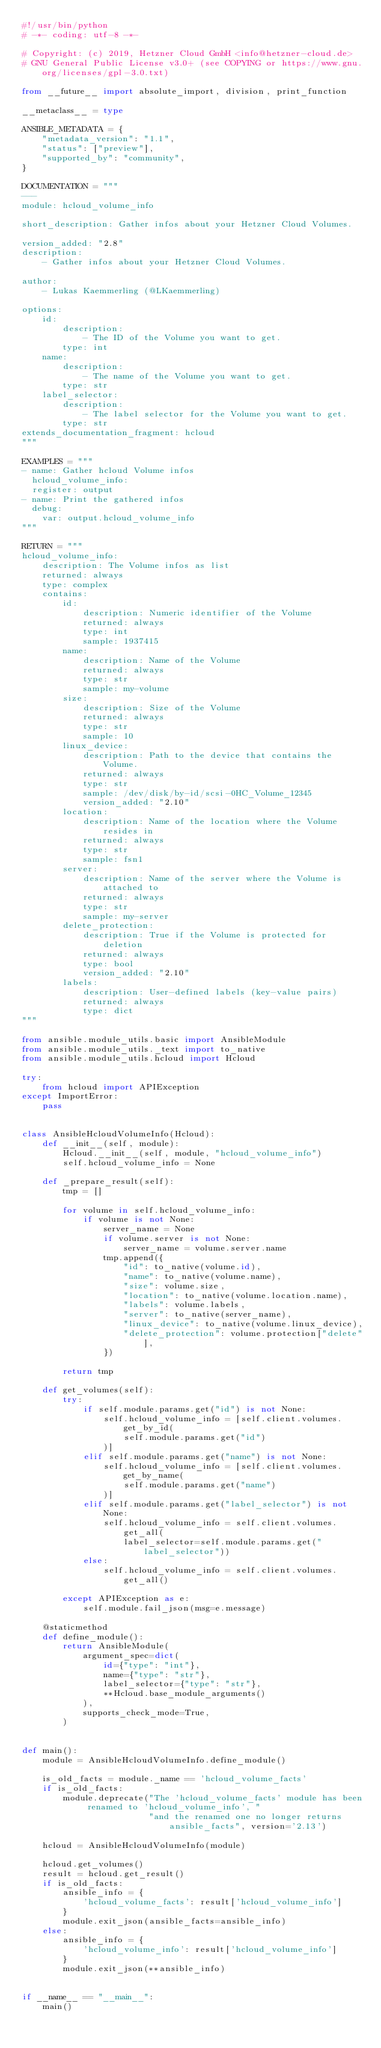Convert code to text. <code><loc_0><loc_0><loc_500><loc_500><_Python_>#!/usr/bin/python
# -*- coding: utf-8 -*-

# Copyright: (c) 2019, Hetzner Cloud GmbH <info@hetzner-cloud.de>
# GNU General Public License v3.0+ (see COPYING or https://www.gnu.org/licenses/gpl-3.0.txt)

from __future__ import absolute_import, division, print_function

__metaclass__ = type

ANSIBLE_METADATA = {
    "metadata_version": "1.1",
    "status": ["preview"],
    "supported_by": "community",
}

DOCUMENTATION = """
---
module: hcloud_volume_info

short_description: Gather infos about your Hetzner Cloud Volumes.

version_added: "2.8"
description:
    - Gather infos about your Hetzner Cloud Volumes.

author:
    - Lukas Kaemmerling (@LKaemmerling)

options:
    id:
        description:
            - The ID of the Volume you want to get.
        type: int
    name:
        description:
            - The name of the Volume you want to get.
        type: str
    label_selector:
        description:
            - The label selector for the Volume you want to get.
        type: str
extends_documentation_fragment: hcloud
"""

EXAMPLES = """
- name: Gather hcloud Volume infos
  hcloud_volume_info:
  register: output
- name: Print the gathered infos
  debug:
    var: output.hcloud_volume_info
"""

RETURN = """
hcloud_volume_info:
    description: The Volume infos as list
    returned: always
    type: complex
    contains:
        id:
            description: Numeric identifier of the Volume
            returned: always
            type: int
            sample: 1937415
        name:
            description: Name of the Volume
            returned: always
            type: str
            sample: my-volume
        size:
            description: Size of the Volume
            returned: always
            type: str
            sample: 10
        linux_device:
            description: Path to the device that contains the Volume.
            returned: always
            type: str
            sample: /dev/disk/by-id/scsi-0HC_Volume_12345
            version_added: "2.10"
        location:
            description: Name of the location where the Volume resides in
            returned: always
            type: str
            sample: fsn1
        server:
            description: Name of the server where the Volume is attached to
            returned: always
            type: str
            sample: my-server
        delete_protection:
            description: True if the Volume is protected for deletion
            returned: always
            type: bool
            version_added: "2.10"
        labels:
            description: User-defined labels (key-value pairs)
            returned: always
            type: dict
"""

from ansible.module_utils.basic import AnsibleModule
from ansible.module_utils._text import to_native
from ansible.module_utils.hcloud import Hcloud

try:
    from hcloud import APIException
except ImportError:
    pass


class AnsibleHcloudVolumeInfo(Hcloud):
    def __init__(self, module):
        Hcloud.__init__(self, module, "hcloud_volume_info")
        self.hcloud_volume_info = None

    def _prepare_result(self):
        tmp = []

        for volume in self.hcloud_volume_info:
            if volume is not None:
                server_name = None
                if volume.server is not None:
                    server_name = volume.server.name
                tmp.append({
                    "id": to_native(volume.id),
                    "name": to_native(volume.name),
                    "size": volume.size,
                    "location": to_native(volume.location.name),
                    "labels": volume.labels,
                    "server": to_native(server_name),
                    "linux_device": to_native(volume.linux_device),
                    "delete_protection": volume.protection["delete"],
                })

        return tmp

    def get_volumes(self):
        try:
            if self.module.params.get("id") is not None:
                self.hcloud_volume_info = [self.client.volumes.get_by_id(
                    self.module.params.get("id")
                )]
            elif self.module.params.get("name") is not None:
                self.hcloud_volume_info = [self.client.volumes.get_by_name(
                    self.module.params.get("name")
                )]
            elif self.module.params.get("label_selector") is not None:
                self.hcloud_volume_info = self.client.volumes.get_all(
                    label_selector=self.module.params.get("label_selector"))
            else:
                self.hcloud_volume_info = self.client.volumes.get_all()

        except APIException as e:
            self.module.fail_json(msg=e.message)

    @staticmethod
    def define_module():
        return AnsibleModule(
            argument_spec=dict(
                id={"type": "int"},
                name={"type": "str"},
                label_selector={"type": "str"},
                **Hcloud.base_module_arguments()
            ),
            supports_check_mode=True,
        )


def main():
    module = AnsibleHcloudVolumeInfo.define_module()

    is_old_facts = module._name == 'hcloud_volume_facts'
    if is_old_facts:
        module.deprecate("The 'hcloud_volume_facts' module has been renamed to 'hcloud_volume_info', "
                         "and the renamed one no longer returns ansible_facts", version='2.13')

    hcloud = AnsibleHcloudVolumeInfo(module)

    hcloud.get_volumes()
    result = hcloud.get_result()
    if is_old_facts:
        ansible_info = {
            'hcloud_volume_facts': result['hcloud_volume_info']
        }
        module.exit_json(ansible_facts=ansible_info)
    else:
        ansible_info = {
            'hcloud_volume_info': result['hcloud_volume_info']
        }
        module.exit_json(**ansible_info)


if __name__ == "__main__":
    main()
</code> 